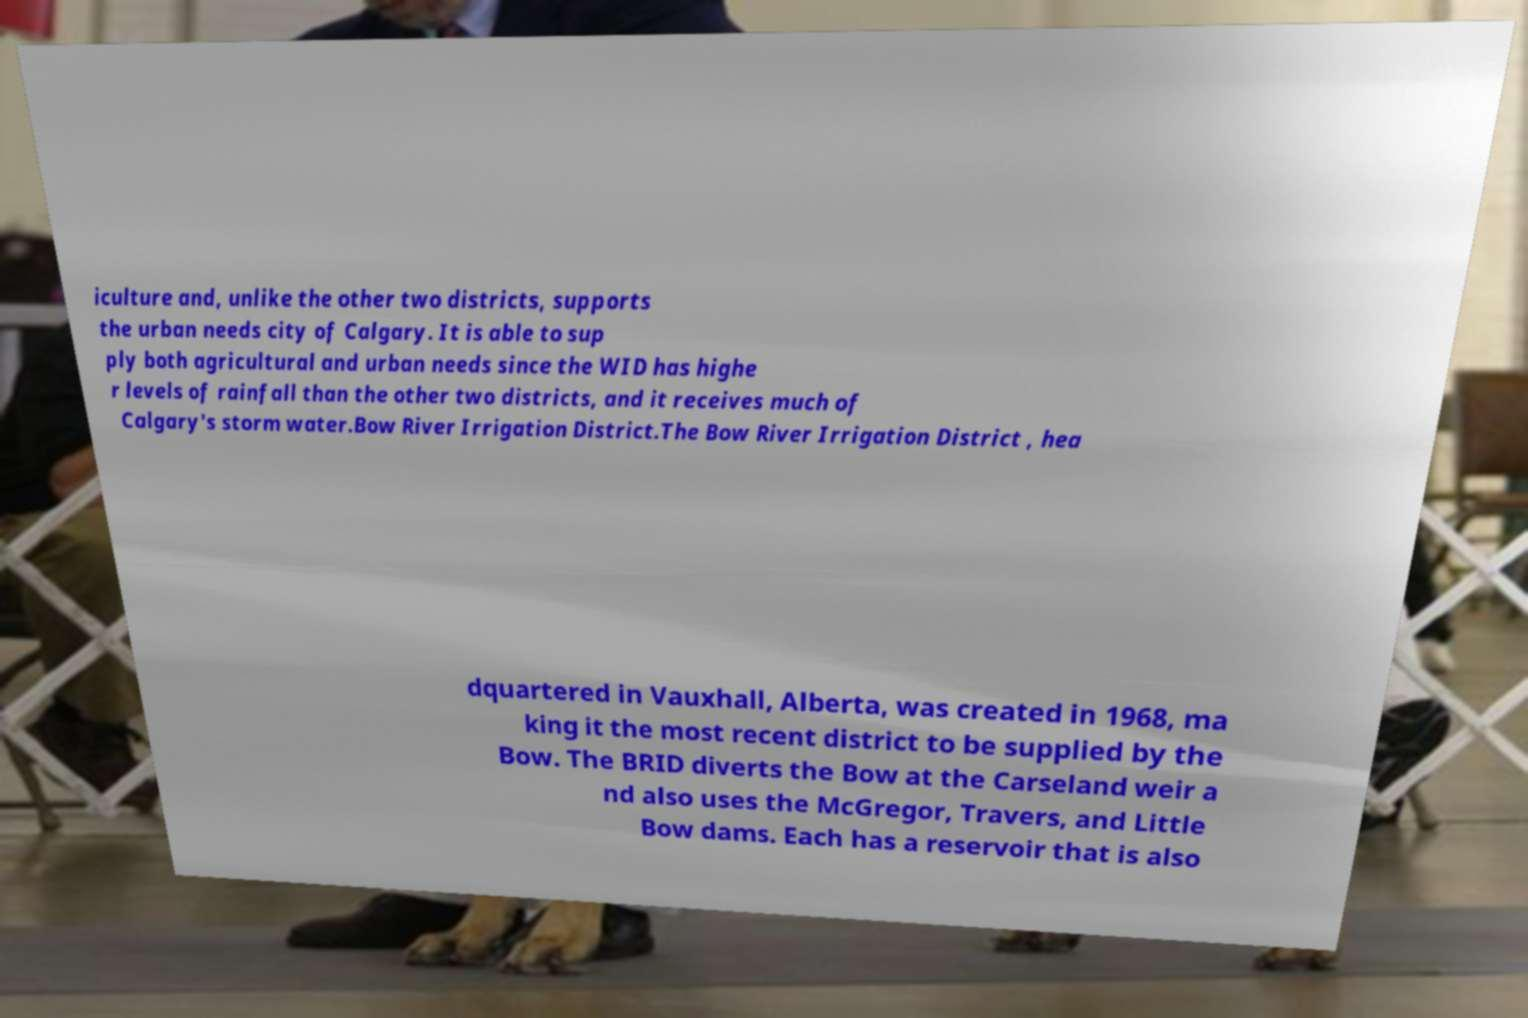Can you read and provide the text displayed in the image?This photo seems to have some interesting text. Can you extract and type it out for me? iculture and, unlike the other two districts, supports the urban needs city of Calgary. It is able to sup ply both agricultural and urban needs since the WID has highe r levels of rainfall than the other two districts, and it receives much of Calgary's storm water.Bow River Irrigation District.The Bow River Irrigation District , hea dquartered in Vauxhall, Alberta, was created in 1968, ma king it the most recent district to be supplied by the Bow. The BRID diverts the Bow at the Carseland weir a nd also uses the McGregor, Travers, and Little Bow dams. Each has a reservoir that is also 